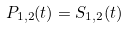Convert formula to latex. <formula><loc_0><loc_0><loc_500><loc_500>P _ { 1 , 2 } ( t ) = S _ { 1 , 2 } ( t )</formula> 